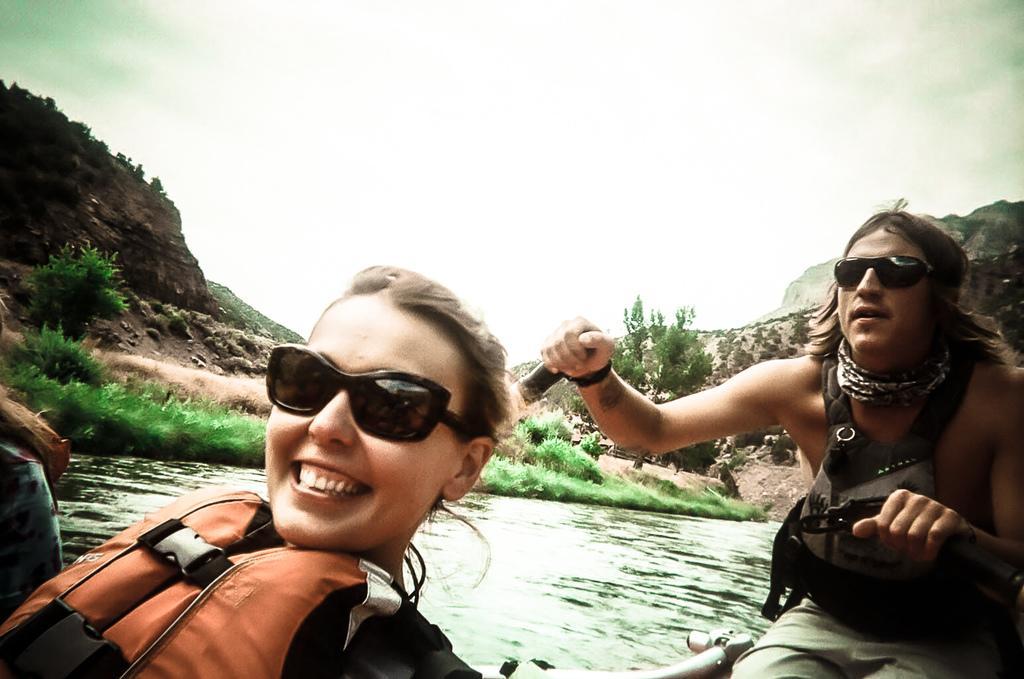Please provide a concise description of this image. Here we can see two persons and she is smiling. This is water. There are plants and this is grass. In the background we can see a mountain and this is sky. 